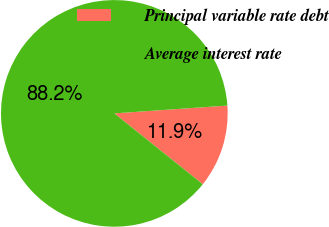Convert chart to OTSL. <chart><loc_0><loc_0><loc_500><loc_500><pie_chart><fcel>Principal variable rate debt<fcel>Average interest rate<nl><fcel>11.85%<fcel>88.15%<nl></chart> 